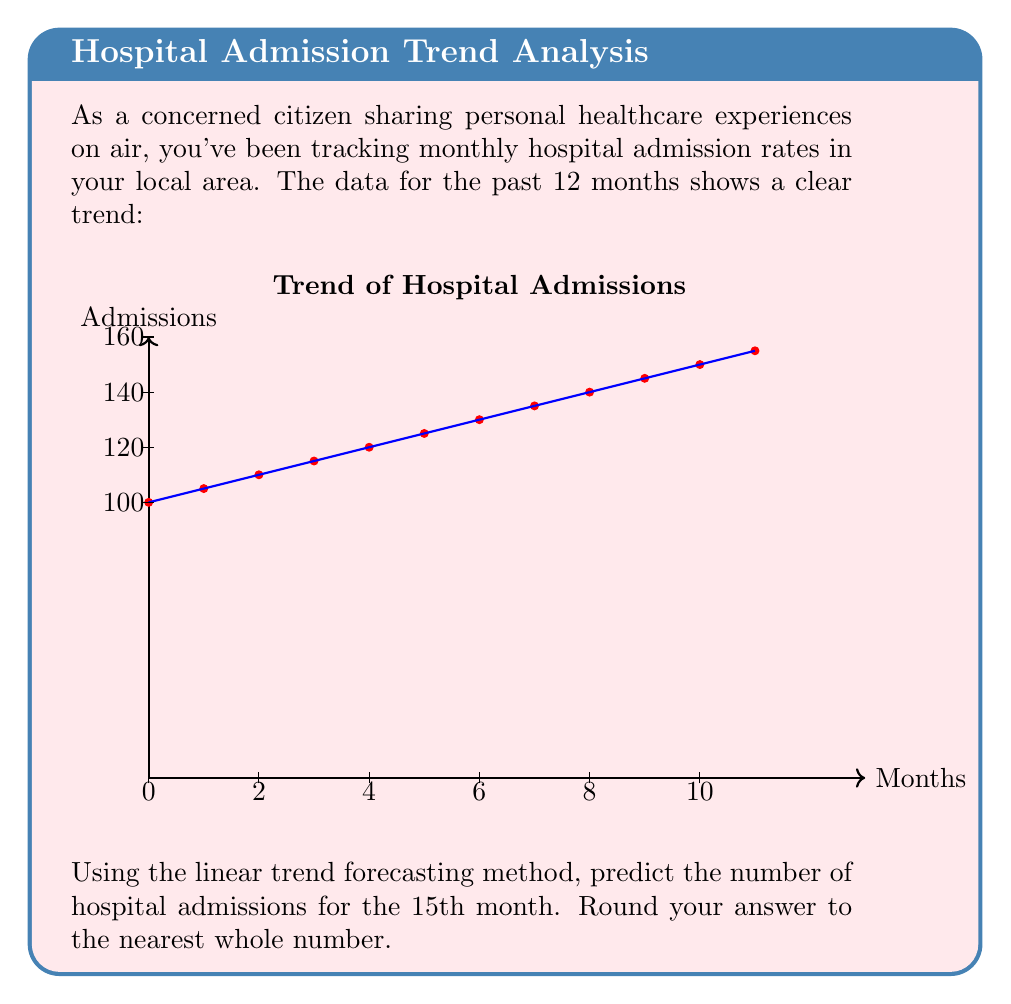What is the answer to this math problem? To solve this problem, we'll use the linear trend forecasting method, which involves these steps:

1) First, we need to find the slope (m) and y-intercept (b) of the line of best fit.

2) The slope can be calculated using the formula:
   $$m = \frac{n\sum xy - \sum x \sum y}{n\sum x^2 - (\sum x)^2}$$
   where n is the number of data points, x represents the month number, and y represents the number of admissions.

3) The y-intercept can be calculated using:
   $$b = \bar{y} - m\bar{x}$$
   where $\bar{x}$ and $\bar{y}$ are the means of x and y respectively.

4) From the graph, we can see that:
   $\sum x = 1+2+3+...+12 = 78$
   $\sum y = 100+105+110+...+155 = 1530$
   $\sum xy = 1(100)+2(105)+3(110)+...+12(155) = 20350$
   $\sum x^2 = 1^2+2^2+3^2+...+12^2 = 650$
   $n = 12$

5) Plugging these into the slope formula:
   $$m = \frac{12(20350) - 78(1530)}{12(650) - 78^2} = 5$$

6) Calculate the means:
   $\bar{x} = 78/12 = 6.5$
   $\bar{y} = 1530/12 = 127.5$

7) Now we can find b:
   $$b = 127.5 - 5(6.5) = 95$$

8) Our line equation is therefore:
   $$y = 5x + 95$$

9) To predict the 15th month, we substitute x = 15:
   $$y = 5(15) + 95 = 170$$

Therefore, the predicted number of hospital admissions for the 15th month is 170.
Answer: 170 